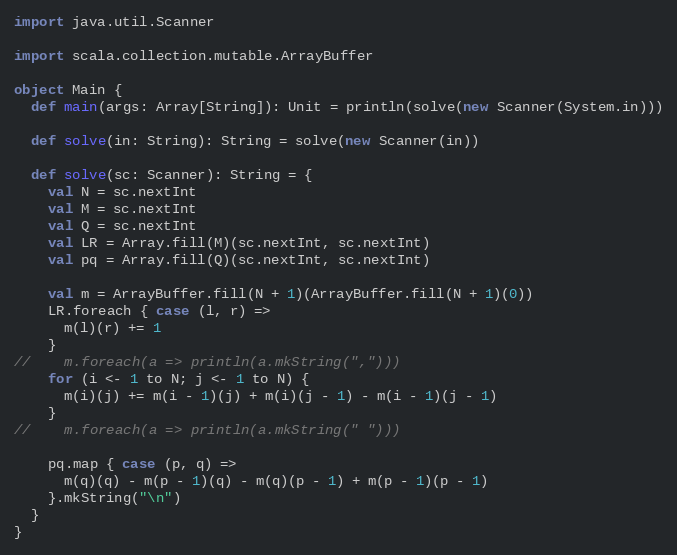<code> <loc_0><loc_0><loc_500><loc_500><_Scala_>import java.util.Scanner

import scala.collection.mutable.ArrayBuffer

object Main {
  def main(args: Array[String]): Unit = println(solve(new Scanner(System.in)))

  def solve(in: String): String = solve(new Scanner(in))

  def solve(sc: Scanner): String = {
    val N = sc.nextInt
    val M = sc.nextInt
    val Q = sc.nextInt
    val LR = Array.fill(M)(sc.nextInt, sc.nextInt)
    val pq = Array.fill(Q)(sc.nextInt, sc.nextInt)

    val m = ArrayBuffer.fill(N + 1)(ArrayBuffer.fill(N + 1)(0))
    LR.foreach { case (l, r) =>
      m(l)(r) += 1
    }
//    m.foreach(a => println(a.mkString(",")))
    for (i <- 1 to N; j <- 1 to N) {
      m(i)(j) += m(i - 1)(j) + m(i)(j - 1) - m(i - 1)(j - 1)
    }
//    m.foreach(a => println(a.mkString(" ")))

    pq.map { case (p, q) =>
      m(q)(q) - m(p - 1)(q) - m(q)(p - 1) + m(p - 1)(p - 1)
    }.mkString("\n")
  }
}
</code> 